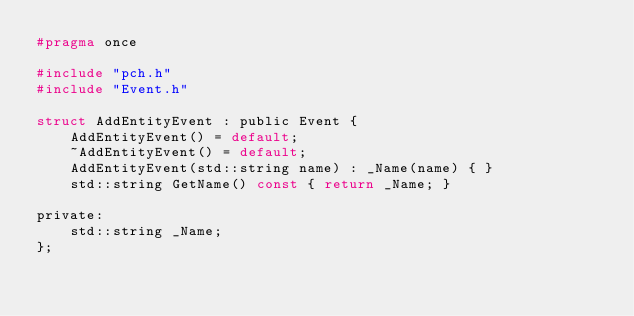<code> <loc_0><loc_0><loc_500><loc_500><_C_>#pragma once

#include "pch.h"
#include "Event.h"

struct AddEntityEvent : public Event {
    AddEntityEvent() = default;
    ~AddEntityEvent() = default;
    AddEntityEvent(std::string name) : _Name(name) { }
    std::string GetName() const { return _Name; }

private:
    std::string _Name;
};</code> 